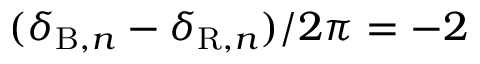Convert formula to latex. <formula><loc_0><loc_0><loc_500><loc_500>( \delta _ { B , n } - \delta _ { R , n } ) / 2 \pi = - 2</formula> 